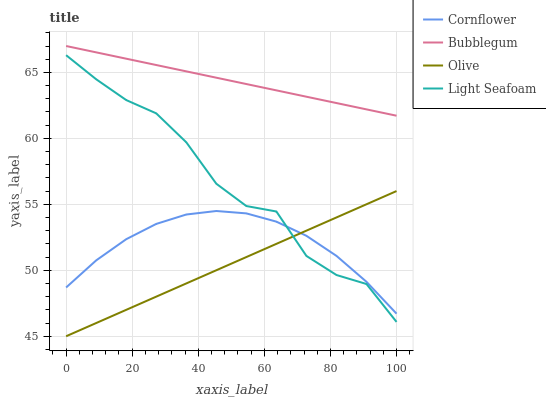Does Olive have the minimum area under the curve?
Answer yes or no. Yes. Does Bubblegum have the maximum area under the curve?
Answer yes or no. Yes. Does Cornflower have the minimum area under the curve?
Answer yes or no. No. Does Cornflower have the maximum area under the curve?
Answer yes or no. No. Is Olive the smoothest?
Answer yes or no. Yes. Is Light Seafoam the roughest?
Answer yes or no. Yes. Is Cornflower the smoothest?
Answer yes or no. No. Is Cornflower the roughest?
Answer yes or no. No. Does Olive have the lowest value?
Answer yes or no. Yes. Does Cornflower have the lowest value?
Answer yes or no. No. Does Bubblegum have the highest value?
Answer yes or no. Yes. Does Light Seafoam have the highest value?
Answer yes or no. No. Is Light Seafoam less than Bubblegum?
Answer yes or no. Yes. Is Bubblegum greater than Light Seafoam?
Answer yes or no. Yes. Does Light Seafoam intersect Cornflower?
Answer yes or no. Yes. Is Light Seafoam less than Cornflower?
Answer yes or no. No. Is Light Seafoam greater than Cornflower?
Answer yes or no. No. Does Light Seafoam intersect Bubblegum?
Answer yes or no. No. 